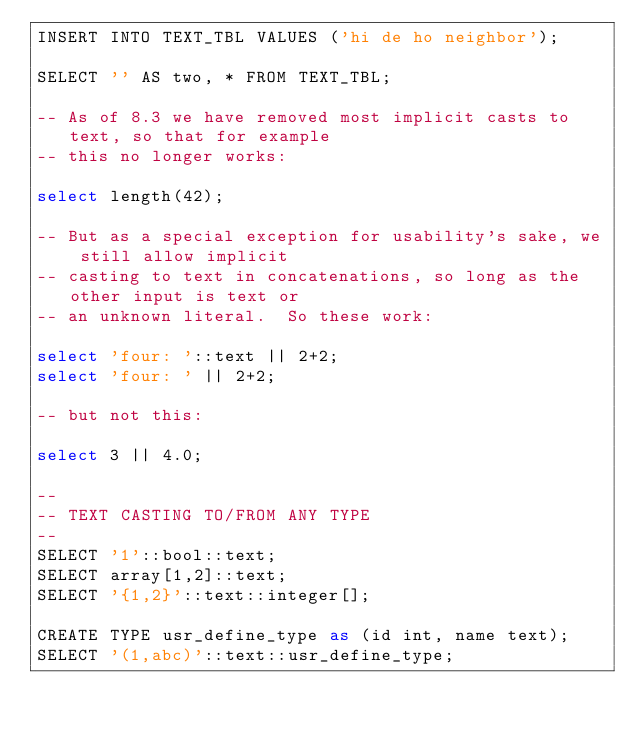<code> <loc_0><loc_0><loc_500><loc_500><_SQL_>INSERT INTO TEXT_TBL VALUES ('hi de ho neighbor');

SELECT '' AS two, * FROM TEXT_TBL;

-- As of 8.3 we have removed most implicit casts to text, so that for example
-- this no longer works:

select length(42);

-- But as a special exception for usability's sake, we still allow implicit
-- casting to text in concatenations, so long as the other input is text or
-- an unknown literal.  So these work:

select 'four: '::text || 2+2;
select 'four: ' || 2+2;

-- but not this:

select 3 || 4.0;

--
-- TEXT CASTING TO/FROM ANY TYPE
--
SELECT '1'::bool::text;
SELECT array[1,2]::text;
SELECT '{1,2}'::text::integer[];

CREATE TYPE usr_define_type as (id int, name text);
SELECT '(1,abc)'::text::usr_define_type;
</code> 